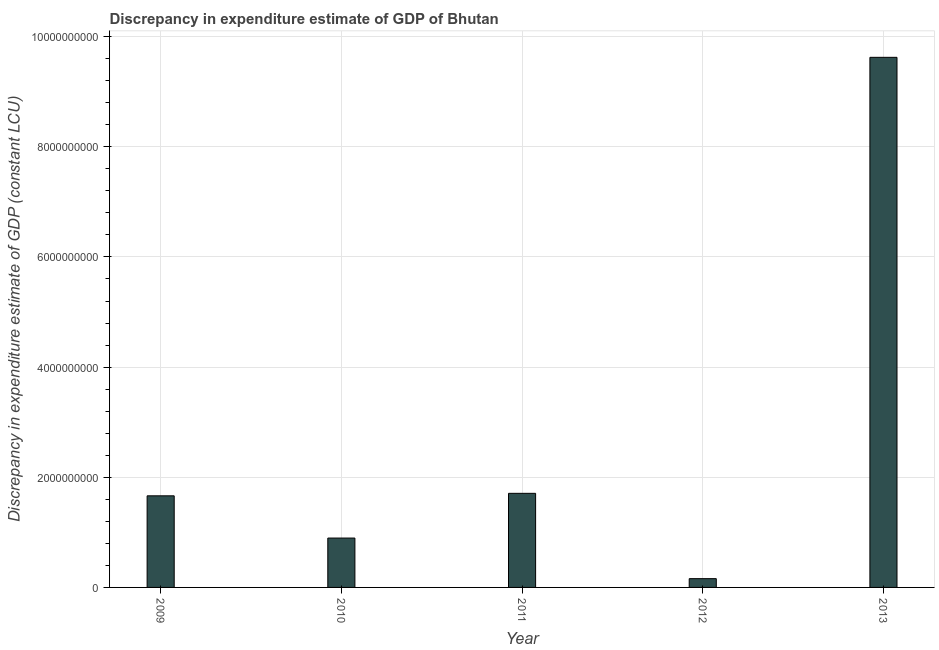Does the graph contain any zero values?
Give a very brief answer. No. What is the title of the graph?
Ensure brevity in your answer.  Discrepancy in expenditure estimate of GDP of Bhutan. What is the label or title of the X-axis?
Ensure brevity in your answer.  Year. What is the label or title of the Y-axis?
Keep it short and to the point. Discrepancy in expenditure estimate of GDP (constant LCU). What is the discrepancy in expenditure estimate of gdp in 2013?
Give a very brief answer. 9.62e+09. Across all years, what is the maximum discrepancy in expenditure estimate of gdp?
Your answer should be very brief. 9.62e+09. Across all years, what is the minimum discrepancy in expenditure estimate of gdp?
Offer a very short reply. 1.59e+08. In which year was the discrepancy in expenditure estimate of gdp maximum?
Provide a short and direct response. 2013. In which year was the discrepancy in expenditure estimate of gdp minimum?
Provide a succinct answer. 2012. What is the sum of the discrepancy in expenditure estimate of gdp?
Offer a very short reply. 1.41e+1. What is the difference between the discrepancy in expenditure estimate of gdp in 2010 and 2012?
Provide a short and direct response. 7.37e+08. What is the average discrepancy in expenditure estimate of gdp per year?
Ensure brevity in your answer.  2.81e+09. What is the median discrepancy in expenditure estimate of gdp?
Provide a succinct answer. 1.66e+09. In how many years, is the discrepancy in expenditure estimate of gdp greater than 8400000000 LCU?
Your answer should be compact. 1. Do a majority of the years between 2009 and 2011 (inclusive) have discrepancy in expenditure estimate of gdp greater than 3200000000 LCU?
Make the answer very short. No. What is the ratio of the discrepancy in expenditure estimate of gdp in 2009 to that in 2012?
Make the answer very short. 10.44. Is the discrepancy in expenditure estimate of gdp in 2010 less than that in 2011?
Your answer should be very brief. Yes. Is the difference between the discrepancy in expenditure estimate of gdp in 2009 and 2011 greater than the difference between any two years?
Offer a very short reply. No. What is the difference between the highest and the second highest discrepancy in expenditure estimate of gdp?
Offer a very short reply. 7.92e+09. What is the difference between the highest and the lowest discrepancy in expenditure estimate of gdp?
Provide a succinct answer. 9.46e+09. Are the values on the major ticks of Y-axis written in scientific E-notation?
Ensure brevity in your answer.  No. What is the Discrepancy in expenditure estimate of GDP (constant LCU) of 2009?
Your response must be concise. 1.66e+09. What is the Discrepancy in expenditure estimate of GDP (constant LCU) in 2010?
Offer a terse response. 8.96e+08. What is the Discrepancy in expenditure estimate of GDP (constant LCU) of 2011?
Offer a terse response. 1.71e+09. What is the Discrepancy in expenditure estimate of GDP (constant LCU) of 2012?
Give a very brief answer. 1.59e+08. What is the Discrepancy in expenditure estimate of GDP (constant LCU) in 2013?
Provide a short and direct response. 9.62e+09. What is the difference between the Discrepancy in expenditure estimate of GDP (constant LCU) in 2009 and 2010?
Give a very brief answer. 7.67e+08. What is the difference between the Discrepancy in expenditure estimate of GDP (constant LCU) in 2009 and 2011?
Provide a short and direct response. -4.51e+07. What is the difference between the Discrepancy in expenditure estimate of GDP (constant LCU) in 2009 and 2012?
Offer a very short reply. 1.50e+09. What is the difference between the Discrepancy in expenditure estimate of GDP (constant LCU) in 2009 and 2013?
Your response must be concise. -7.96e+09. What is the difference between the Discrepancy in expenditure estimate of GDP (constant LCU) in 2010 and 2011?
Keep it short and to the point. -8.12e+08. What is the difference between the Discrepancy in expenditure estimate of GDP (constant LCU) in 2010 and 2012?
Ensure brevity in your answer.  7.37e+08. What is the difference between the Discrepancy in expenditure estimate of GDP (constant LCU) in 2010 and 2013?
Provide a short and direct response. -8.73e+09. What is the difference between the Discrepancy in expenditure estimate of GDP (constant LCU) in 2011 and 2012?
Offer a terse response. 1.55e+09. What is the difference between the Discrepancy in expenditure estimate of GDP (constant LCU) in 2011 and 2013?
Keep it short and to the point. -7.92e+09. What is the difference between the Discrepancy in expenditure estimate of GDP (constant LCU) in 2012 and 2013?
Keep it short and to the point. -9.46e+09. What is the ratio of the Discrepancy in expenditure estimate of GDP (constant LCU) in 2009 to that in 2010?
Provide a succinct answer. 1.86. What is the ratio of the Discrepancy in expenditure estimate of GDP (constant LCU) in 2009 to that in 2011?
Offer a terse response. 0.97. What is the ratio of the Discrepancy in expenditure estimate of GDP (constant LCU) in 2009 to that in 2012?
Give a very brief answer. 10.44. What is the ratio of the Discrepancy in expenditure estimate of GDP (constant LCU) in 2009 to that in 2013?
Keep it short and to the point. 0.17. What is the ratio of the Discrepancy in expenditure estimate of GDP (constant LCU) in 2010 to that in 2011?
Provide a short and direct response. 0.53. What is the ratio of the Discrepancy in expenditure estimate of GDP (constant LCU) in 2010 to that in 2012?
Offer a very short reply. 5.62. What is the ratio of the Discrepancy in expenditure estimate of GDP (constant LCU) in 2010 to that in 2013?
Make the answer very short. 0.09. What is the ratio of the Discrepancy in expenditure estimate of GDP (constant LCU) in 2011 to that in 2012?
Your answer should be very brief. 10.72. What is the ratio of the Discrepancy in expenditure estimate of GDP (constant LCU) in 2011 to that in 2013?
Your response must be concise. 0.18. What is the ratio of the Discrepancy in expenditure estimate of GDP (constant LCU) in 2012 to that in 2013?
Keep it short and to the point. 0.02. 